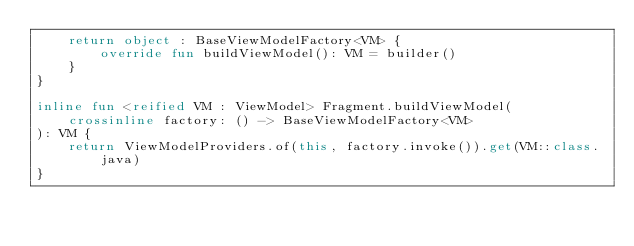Convert code to text. <code><loc_0><loc_0><loc_500><loc_500><_Kotlin_>    return object : BaseViewModelFactory<VM> {
        override fun buildViewModel(): VM = builder()
    }
}

inline fun <reified VM : ViewModel> Fragment.buildViewModel(
    crossinline factory: () -> BaseViewModelFactory<VM>
): VM {
    return ViewModelProviders.of(this, factory.invoke()).get(VM::class.java)
}</code> 